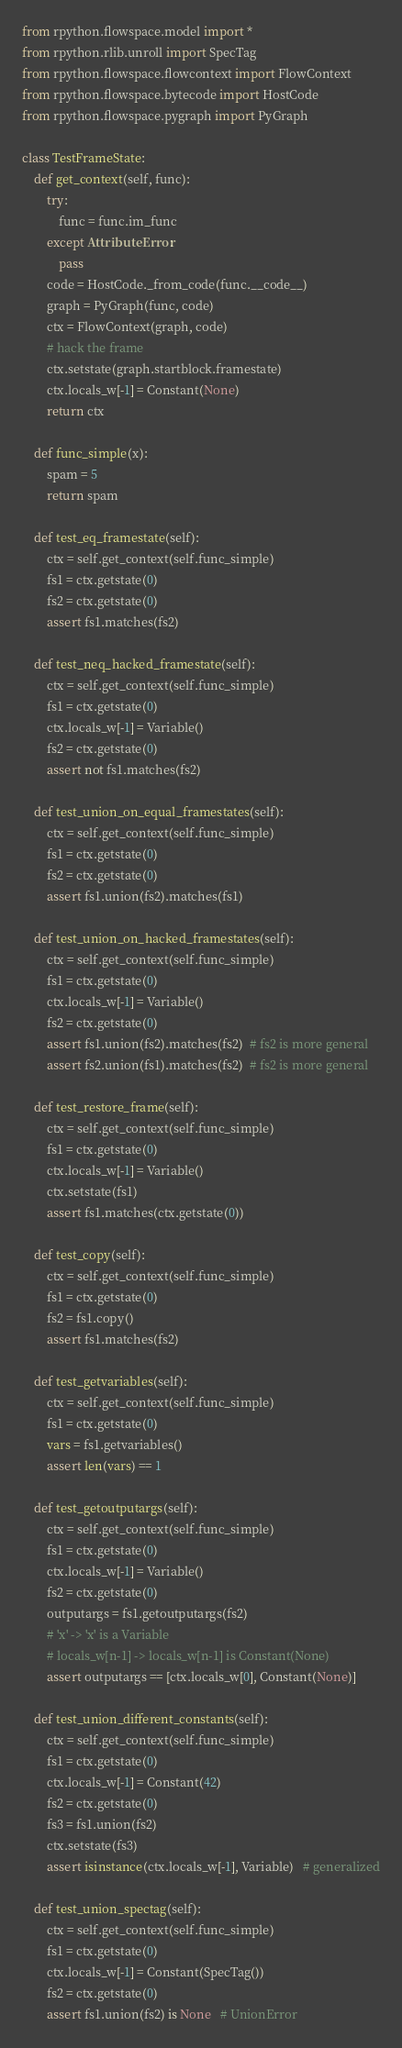Convert code to text. <code><loc_0><loc_0><loc_500><loc_500><_Python_>from rpython.flowspace.model import *
from rpython.rlib.unroll import SpecTag
from rpython.flowspace.flowcontext import FlowContext
from rpython.flowspace.bytecode import HostCode
from rpython.flowspace.pygraph import PyGraph

class TestFrameState:
    def get_context(self, func):
        try:
            func = func.im_func
        except AttributeError:
            pass
        code = HostCode._from_code(func.__code__)
        graph = PyGraph(func, code)
        ctx = FlowContext(graph, code)
        # hack the frame
        ctx.setstate(graph.startblock.framestate)
        ctx.locals_w[-1] = Constant(None)
        return ctx

    def func_simple(x):
        spam = 5
        return spam

    def test_eq_framestate(self):
        ctx = self.get_context(self.func_simple)
        fs1 = ctx.getstate(0)
        fs2 = ctx.getstate(0)
        assert fs1.matches(fs2)

    def test_neq_hacked_framestate(self):
        ctx = self.get_context(self.func_simple)
        fs1 = ctx.getstate(0)
        ctx.locals_w[-1] = Variable()
        fs2 = ctx.getstate(0)
        assert not fs1.matches(fs2)

    def test_union_on_equal_framestates(self):
        ctx = self.get_context(self.func_simple)
        fs1 = ctx.getstate(0)
        fs2 = ctx.getstate(0)
        assert fs1.union(fs2).matches(fs1)

    def test_union_on_hacked_framestates(self):
        ctx = self.get_context(self.func_simple)
        fs1 = ctx.getstate(0)
        ctx.locals_w[-1] = Variable()
        fs2 = ctx.getstate(0)
        assert fs1.union(fs2).matches(fs2)  # fs2 is more general
        assert fs2.union(fs1).matches(fs2)  # fs2 is more general

    def test_restore_frame(self):
        ctx = self.get_context(self.func_simple)
        fs1 = ctx.getstate(0)
        ctx.locals_w[-1] = Variable()
        ctx.setstate(fs1)
        assert fs1.matches(ctx.getstate(0))

    def test_copy(self):
        ctx = self.get_context(self.func_simple)
        fs1 = ctx.getstate(0)
        fs2 = fs1.copy()
        assert fs1.matches(fs2)

    def test_getvariables(self):
        ctx = self.get_context(self.func_simple)
        fs1 = ctx.getstate(0)
        vars = fs1.getvariables()
        assert len(vars) == 1

    def test_getoutputargs(self):
        ctx = self.get_context(self.func_simple)
        fs1 = ctx.getstate(0)
        ctx.locals_w[-1] = Variable()
        fs2 = ctx.getstate(0)
        outputargs = fs1.getoutputargs(fs2)
        # 'x' -> 'x' is a Variable
        # locals_w[n-1] -> locals_w[n-1] is Constant(None)
        assert outputargs == [ctx.locals_w[0], Constant(None)]

    def test_union_different_constants(self):
        ctx = self.get_context(self.func_simple)
        fs1 = ctx.getstate(0)
        ctx.locals_w[-1] = Constant(42)
        fs2 = ctx.getstate(0)
        fs3 = fs1.union(fs2)
        ctx.setstate(fs3)
        assert isinstance(ctx.locals_w[-1], Variable)   # generalized

    def test_union_spectag(self):
        ctx = self.get_context(self.func_simple)
        fs1 = ctx.getstate(0)
        ctx.locals_w[-1] = Constant(SpecTag())
        fs2 = ctx.getstate(0)
        assert fs1.union(fs2) is None   # UnionError
</code> 